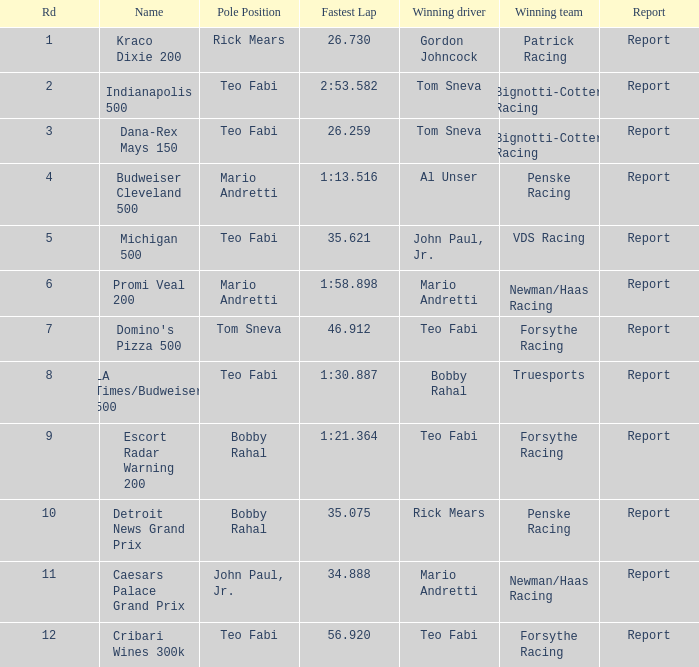In which rd did tom sneva achieve the topmost pole position? 7.0. 